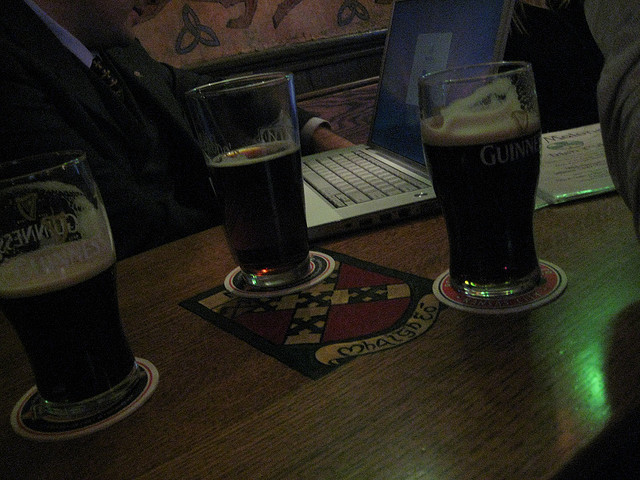Please identify all text content in this image. GUNNE SUNNES 